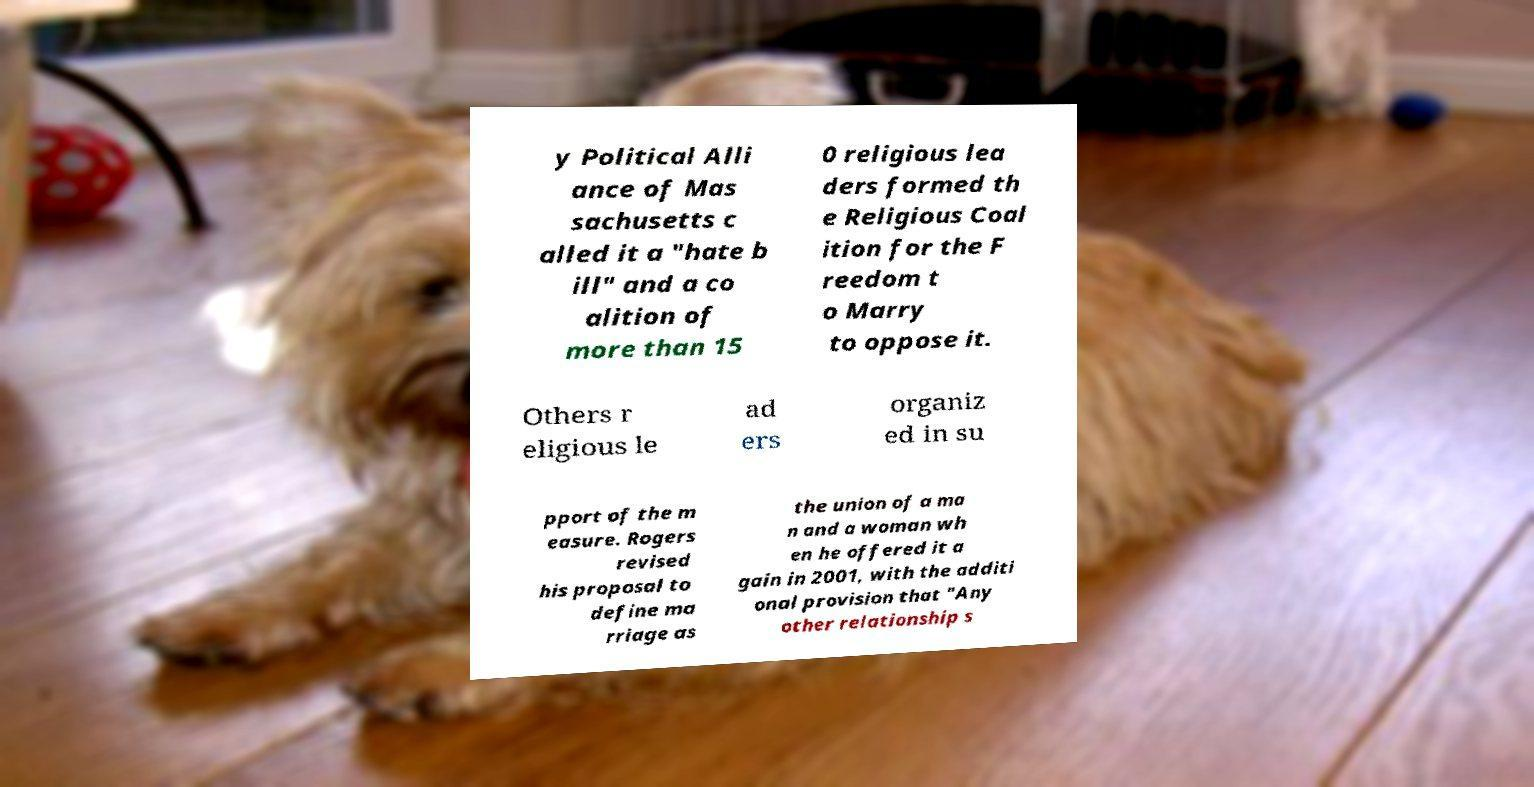There's text embedded in this image that I need extracted. Can you transcribe it verbatim? y Political Alli ance of Mas sachusetts c alled it a "hate b ill" and a co alition of more than 15 0 religious lea ders formed th e Religious Coal ition for the F reedom t o Marry to oppose it. Others r eligious le ad ers organiz ed in su pport of the m easure. Rogers revised his proposal to define ma rriage as the union of a ma n and a woman wh en he offered it a gain in 2001, with the additi onal provision that "Any other relationship s 